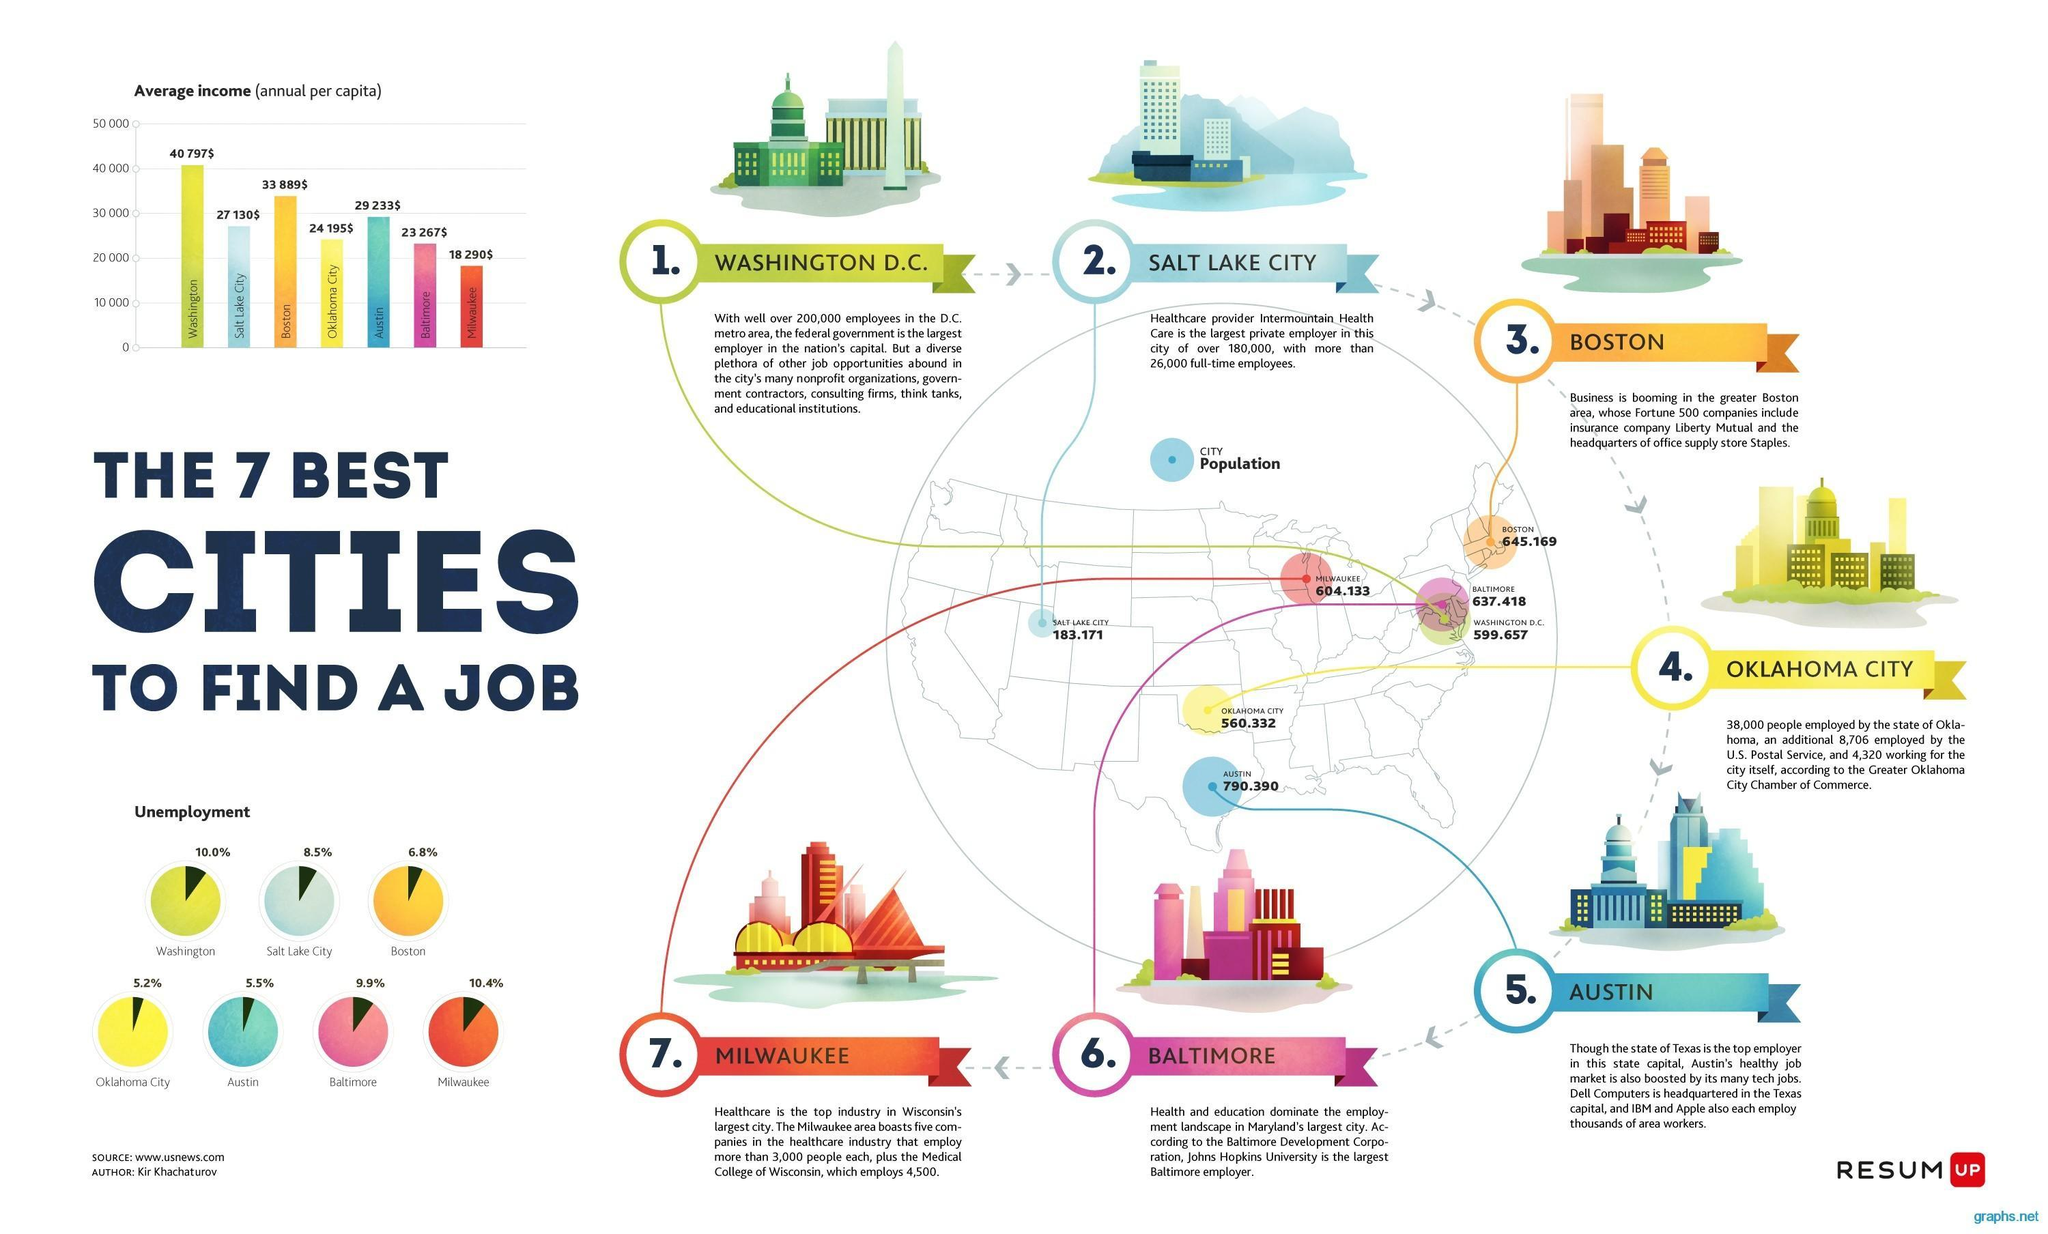What is the employment percentage in Washington?
Answer the question with a short phrase. 90.0% What is the employment percentage in Austin? 94.5% What is the employment percentage in Boston? 93.2% 